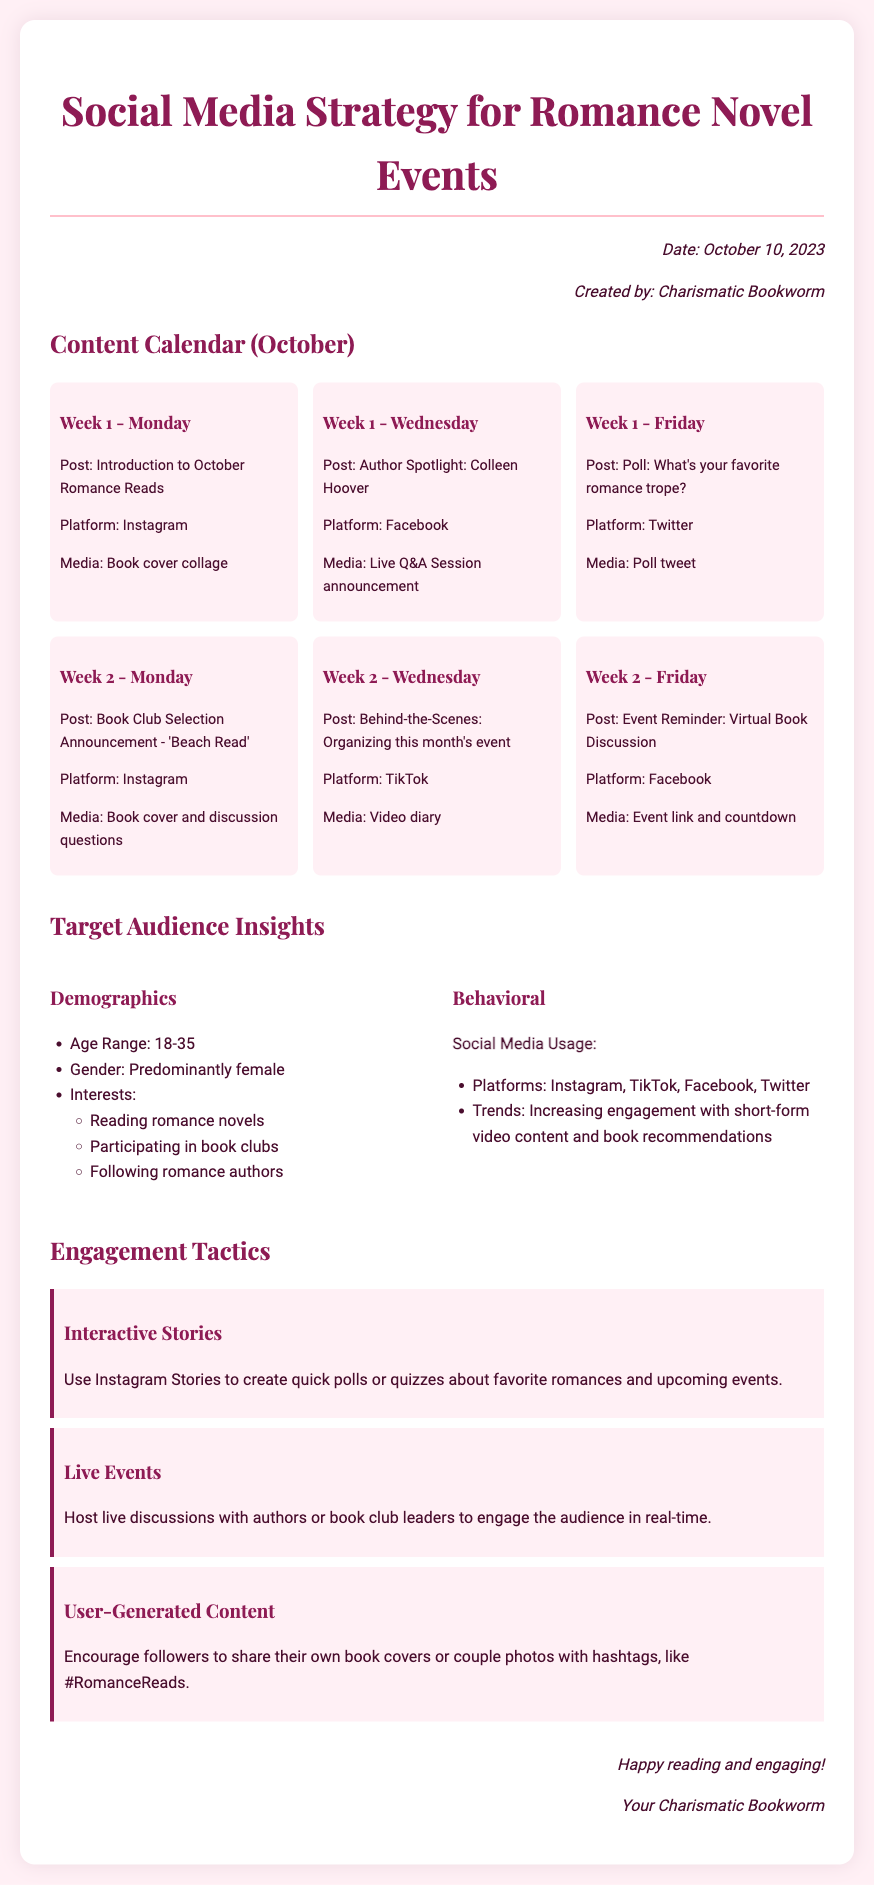What is the date of the memo? The date of the memo is explicitly stated at the top of the document.
Answer: October 10, 2023 Who created the memo? The memo explicitly names the author in the metadata section.
Answer: Charismatic Bookworm What is the age range of the target audience? The target audience insights section includes specific demographic information, including age range.
Answer: 18-35 What is one platform mentioned for the content calendar posts? The content calendar lists various platforms used for posts.
Answer: Instagram What is the title of the book for the book club selection? The book club selection announcement is specified in the content calendar.
Answer: Beach Read What engagement tactic involves polls and quizzes? The engagement tactics section describes techniques for interacting with followers.
Answer: Interactive Stories How many weeks are planned in the content calendar for October? The content calendar covers activities over a specified number of weeks.
Answer: 2 Which author is spotlighted in the content calendar? The content calendar highlights specific authors for posts.
Answer: Colleen Hoover What format is suggested for behind-the-scenes content? The document specifies the media format for certain content pieces.
Answer: Video diary 